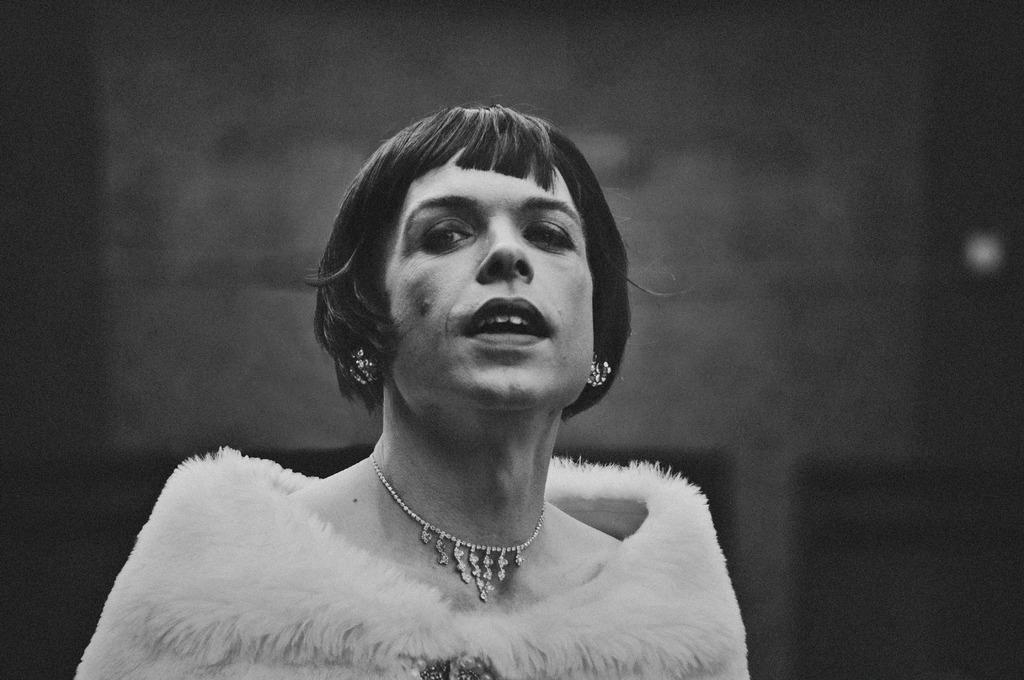Who is the main subject in the image? There is a woman in the image. What is the woman wearing in the image? The woman is wearing a feather jacket and a necklace. What is the color scheme of the image? The image is in black and white color. What is the process of making the feather jacket in the image? There is no information about the process of making the feather jacket in the image. The focus is on the woman wearing the jacket, not the creation of the jacket itself. 